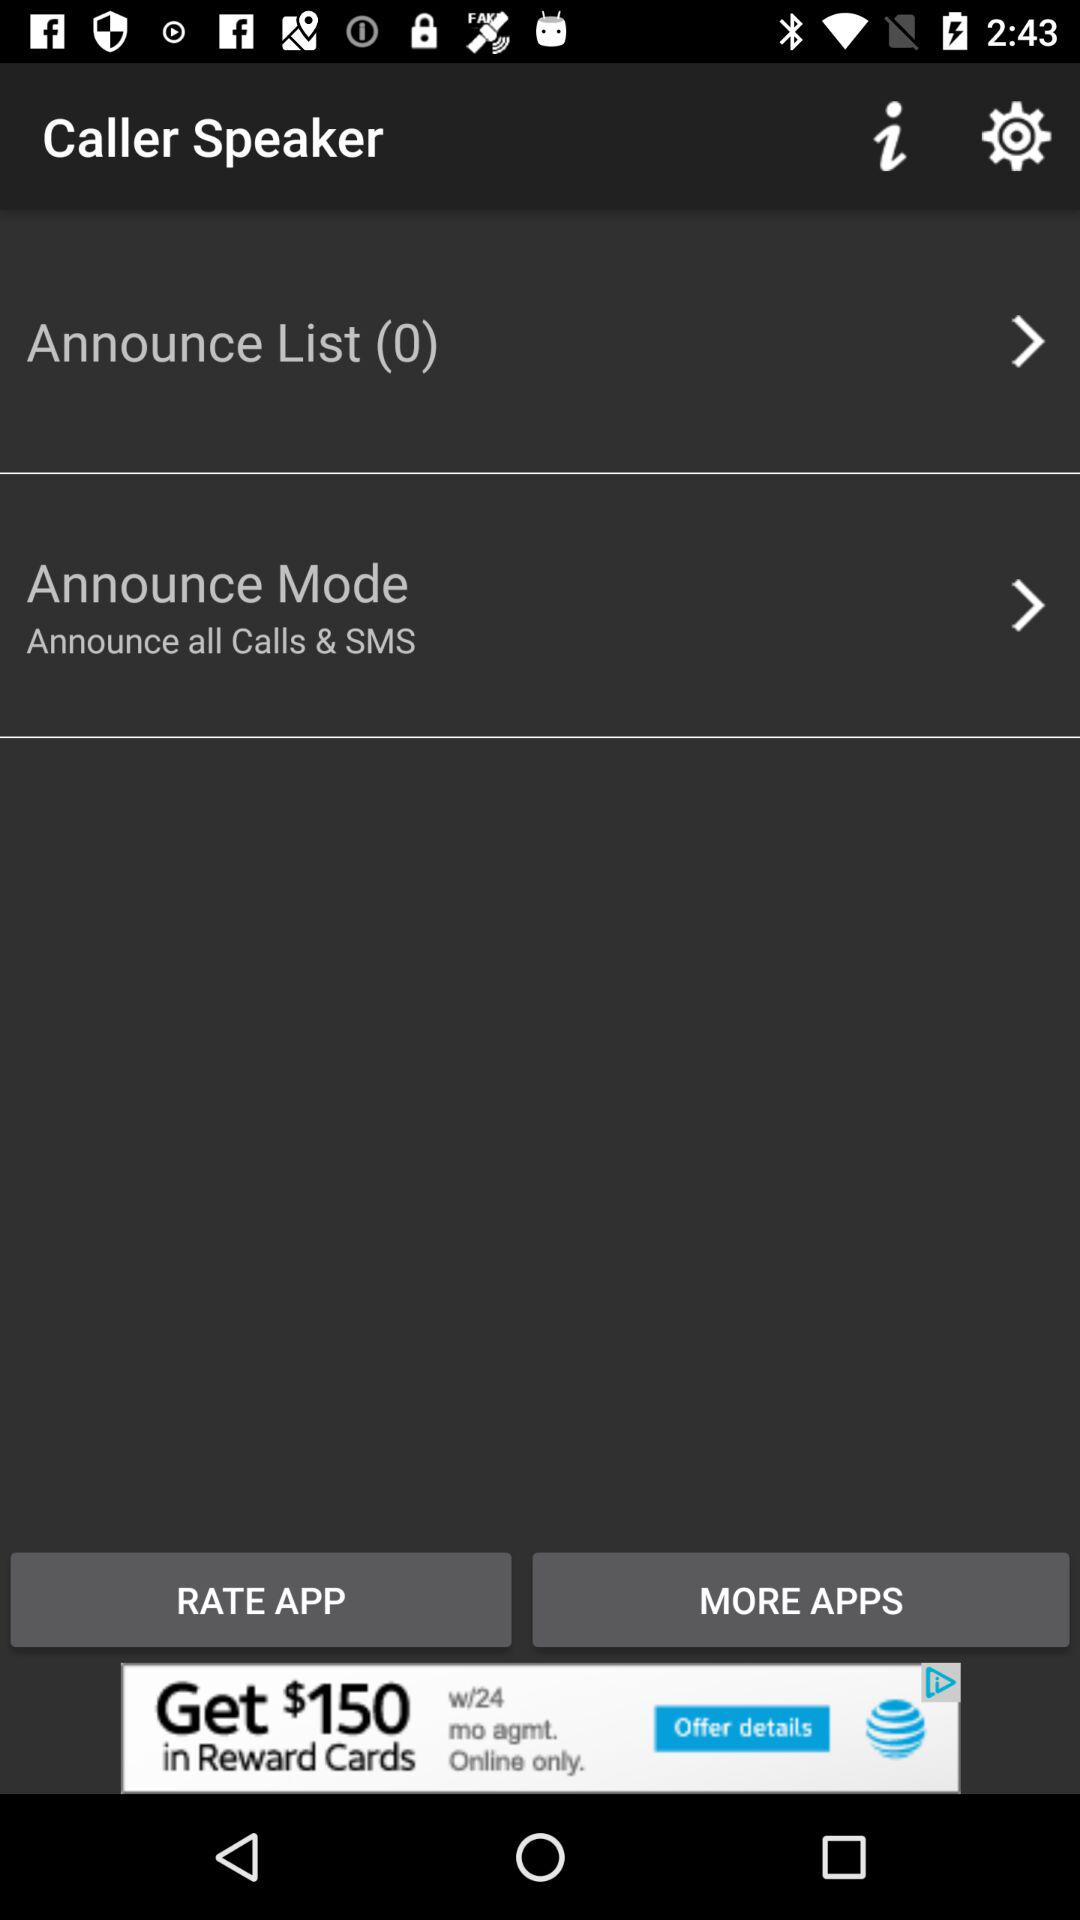How many items are there in "Announce List"? There are 0 items in "Announce List". 